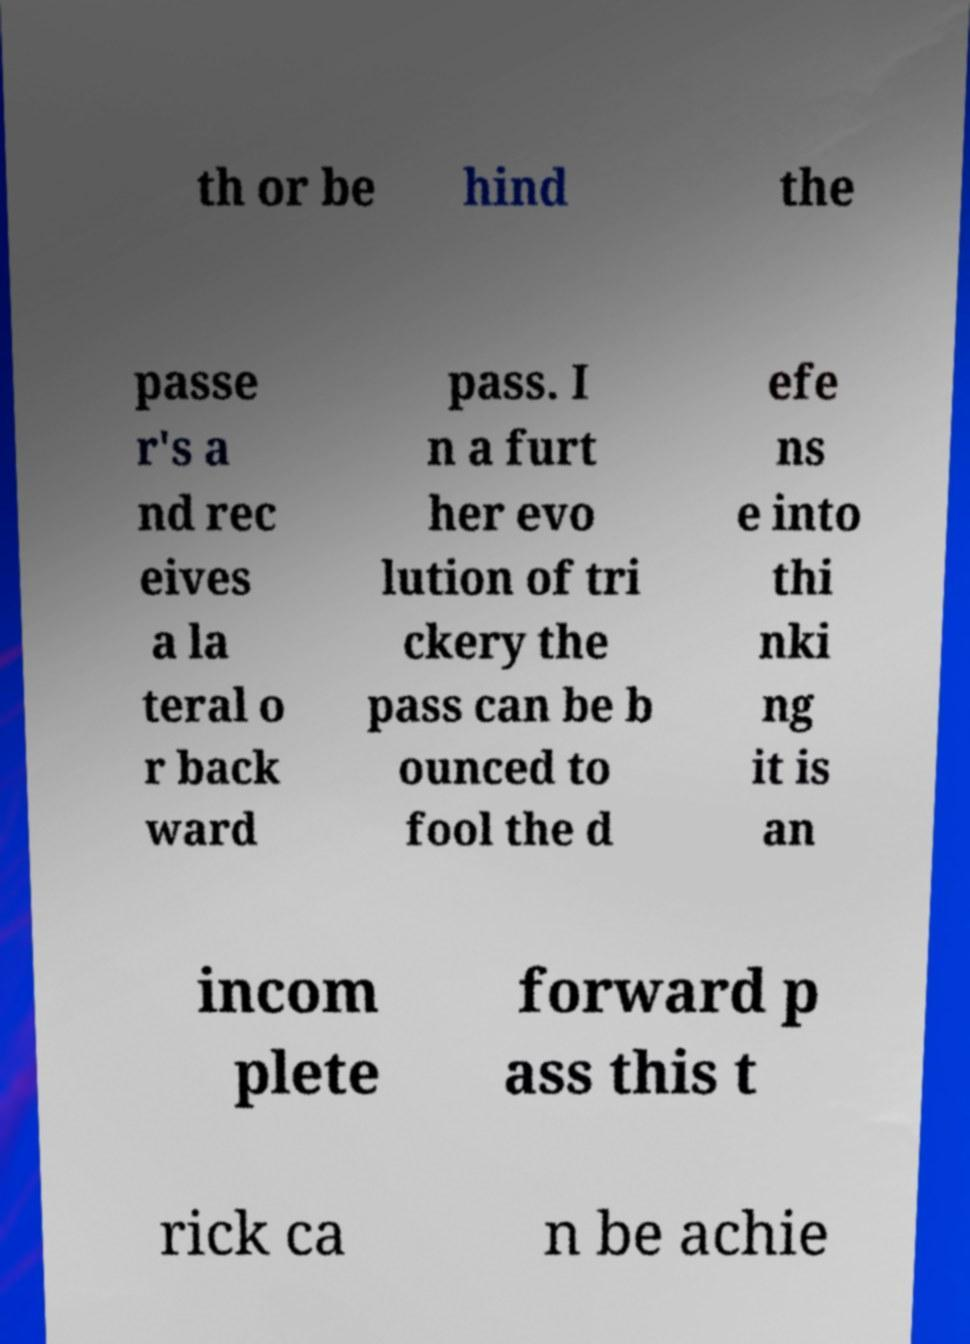I need the written content from this picture converted into text. Can you do that? th or be hind the passe r's a nd rec eives a la teral o r back ward pass. I n a furt her evo lution of tri ckery the pass can be b ounced to fool the d efe ns e into thi nki ng it is an incom plete forward p ass this t rick ca n be achie 